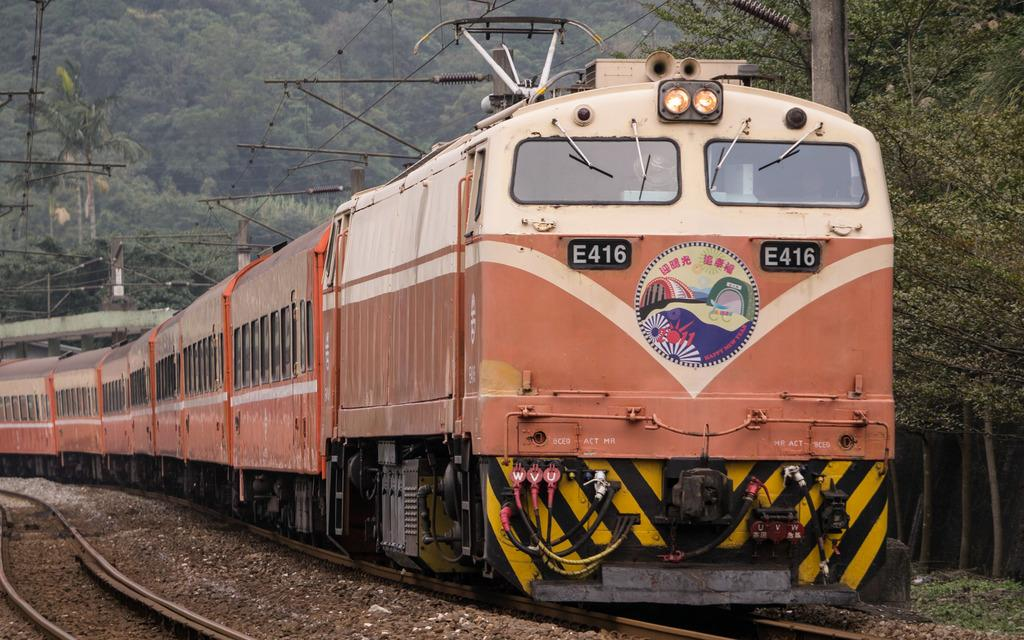Provide a one-sentence caption for the provided image. Train E416 has a 2011 Happy New Year plate on front. 